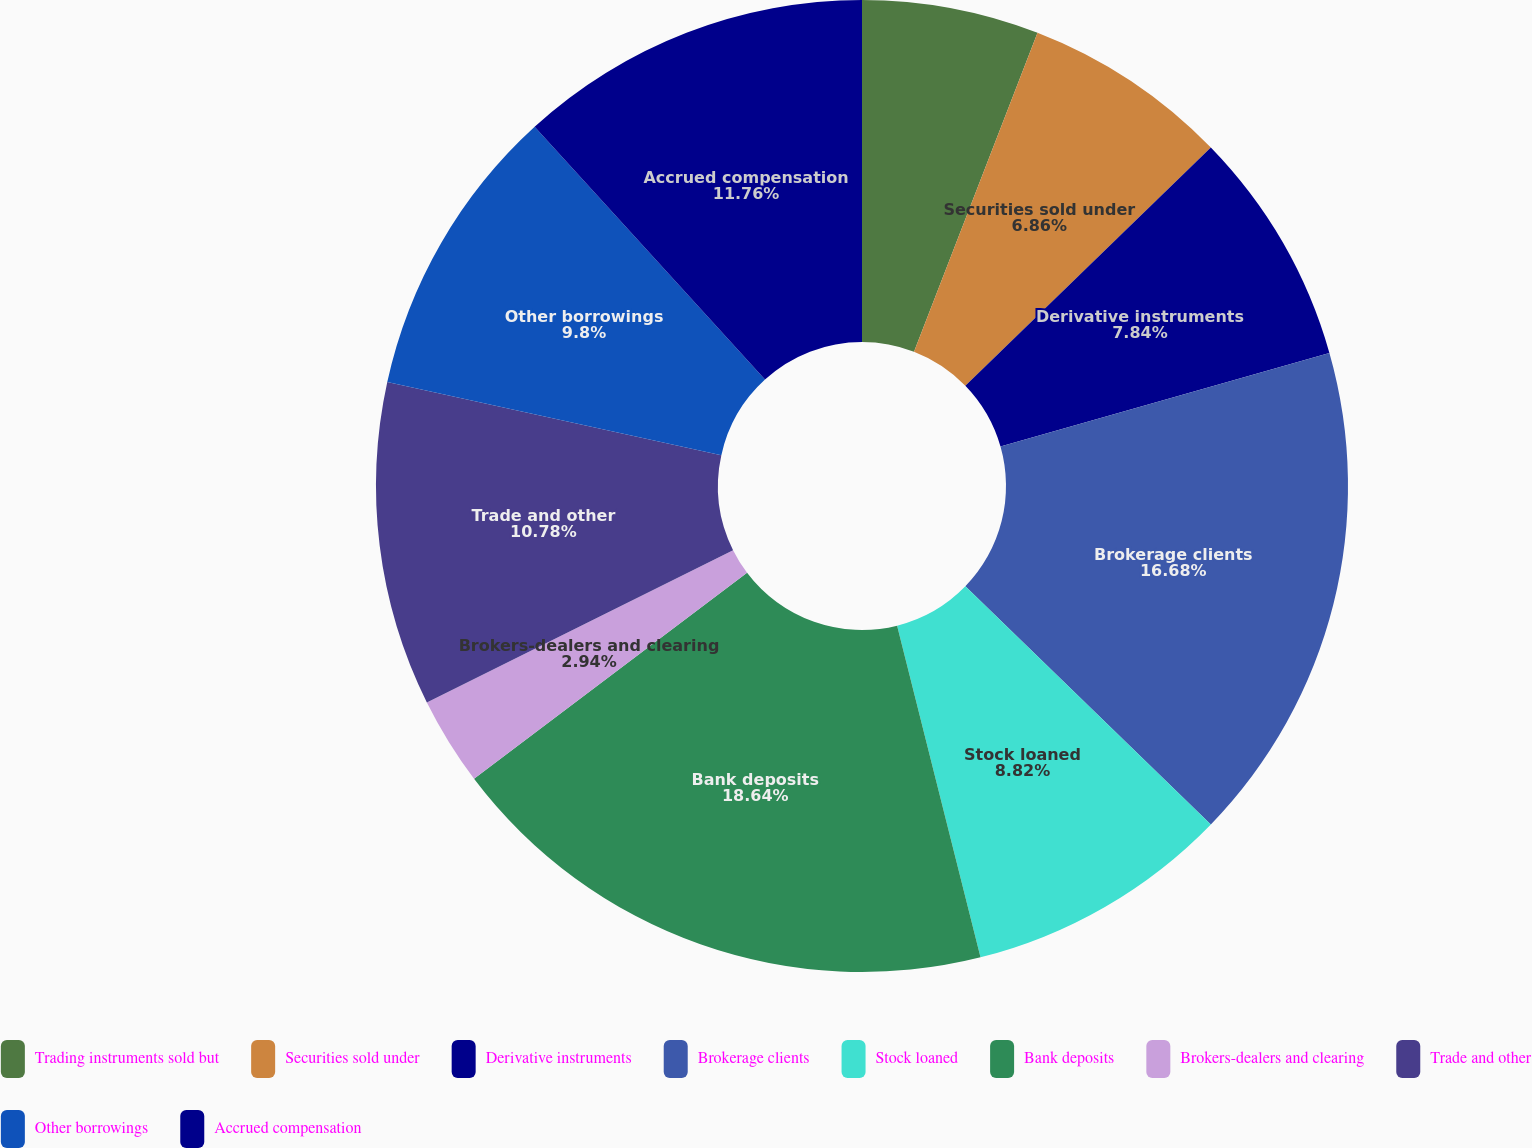<chart> <loc_0><loc_0><loc_500><loc_500><pie_chart><fcel>Trading instruments sold but<fcel>Securities sold under<fcel>Derivative instruments<fcel>Brokerage clients<fcel>Stock loaned<fcel>Bank deposits<fcel>Brokers-dealers and clearing<fcel>Trade and other<fcel>Other borrowings<fcel>Accrued compensation<nl><fcel>5.88%<fcel>6.86%<fcel>7.84%<fcel>16.67%<fcel>8.82%<fcel>18.63%<fcel>2.94%<fcel>10.78%<fcel>9.8%<fcel>11.76%<nl></chart> 